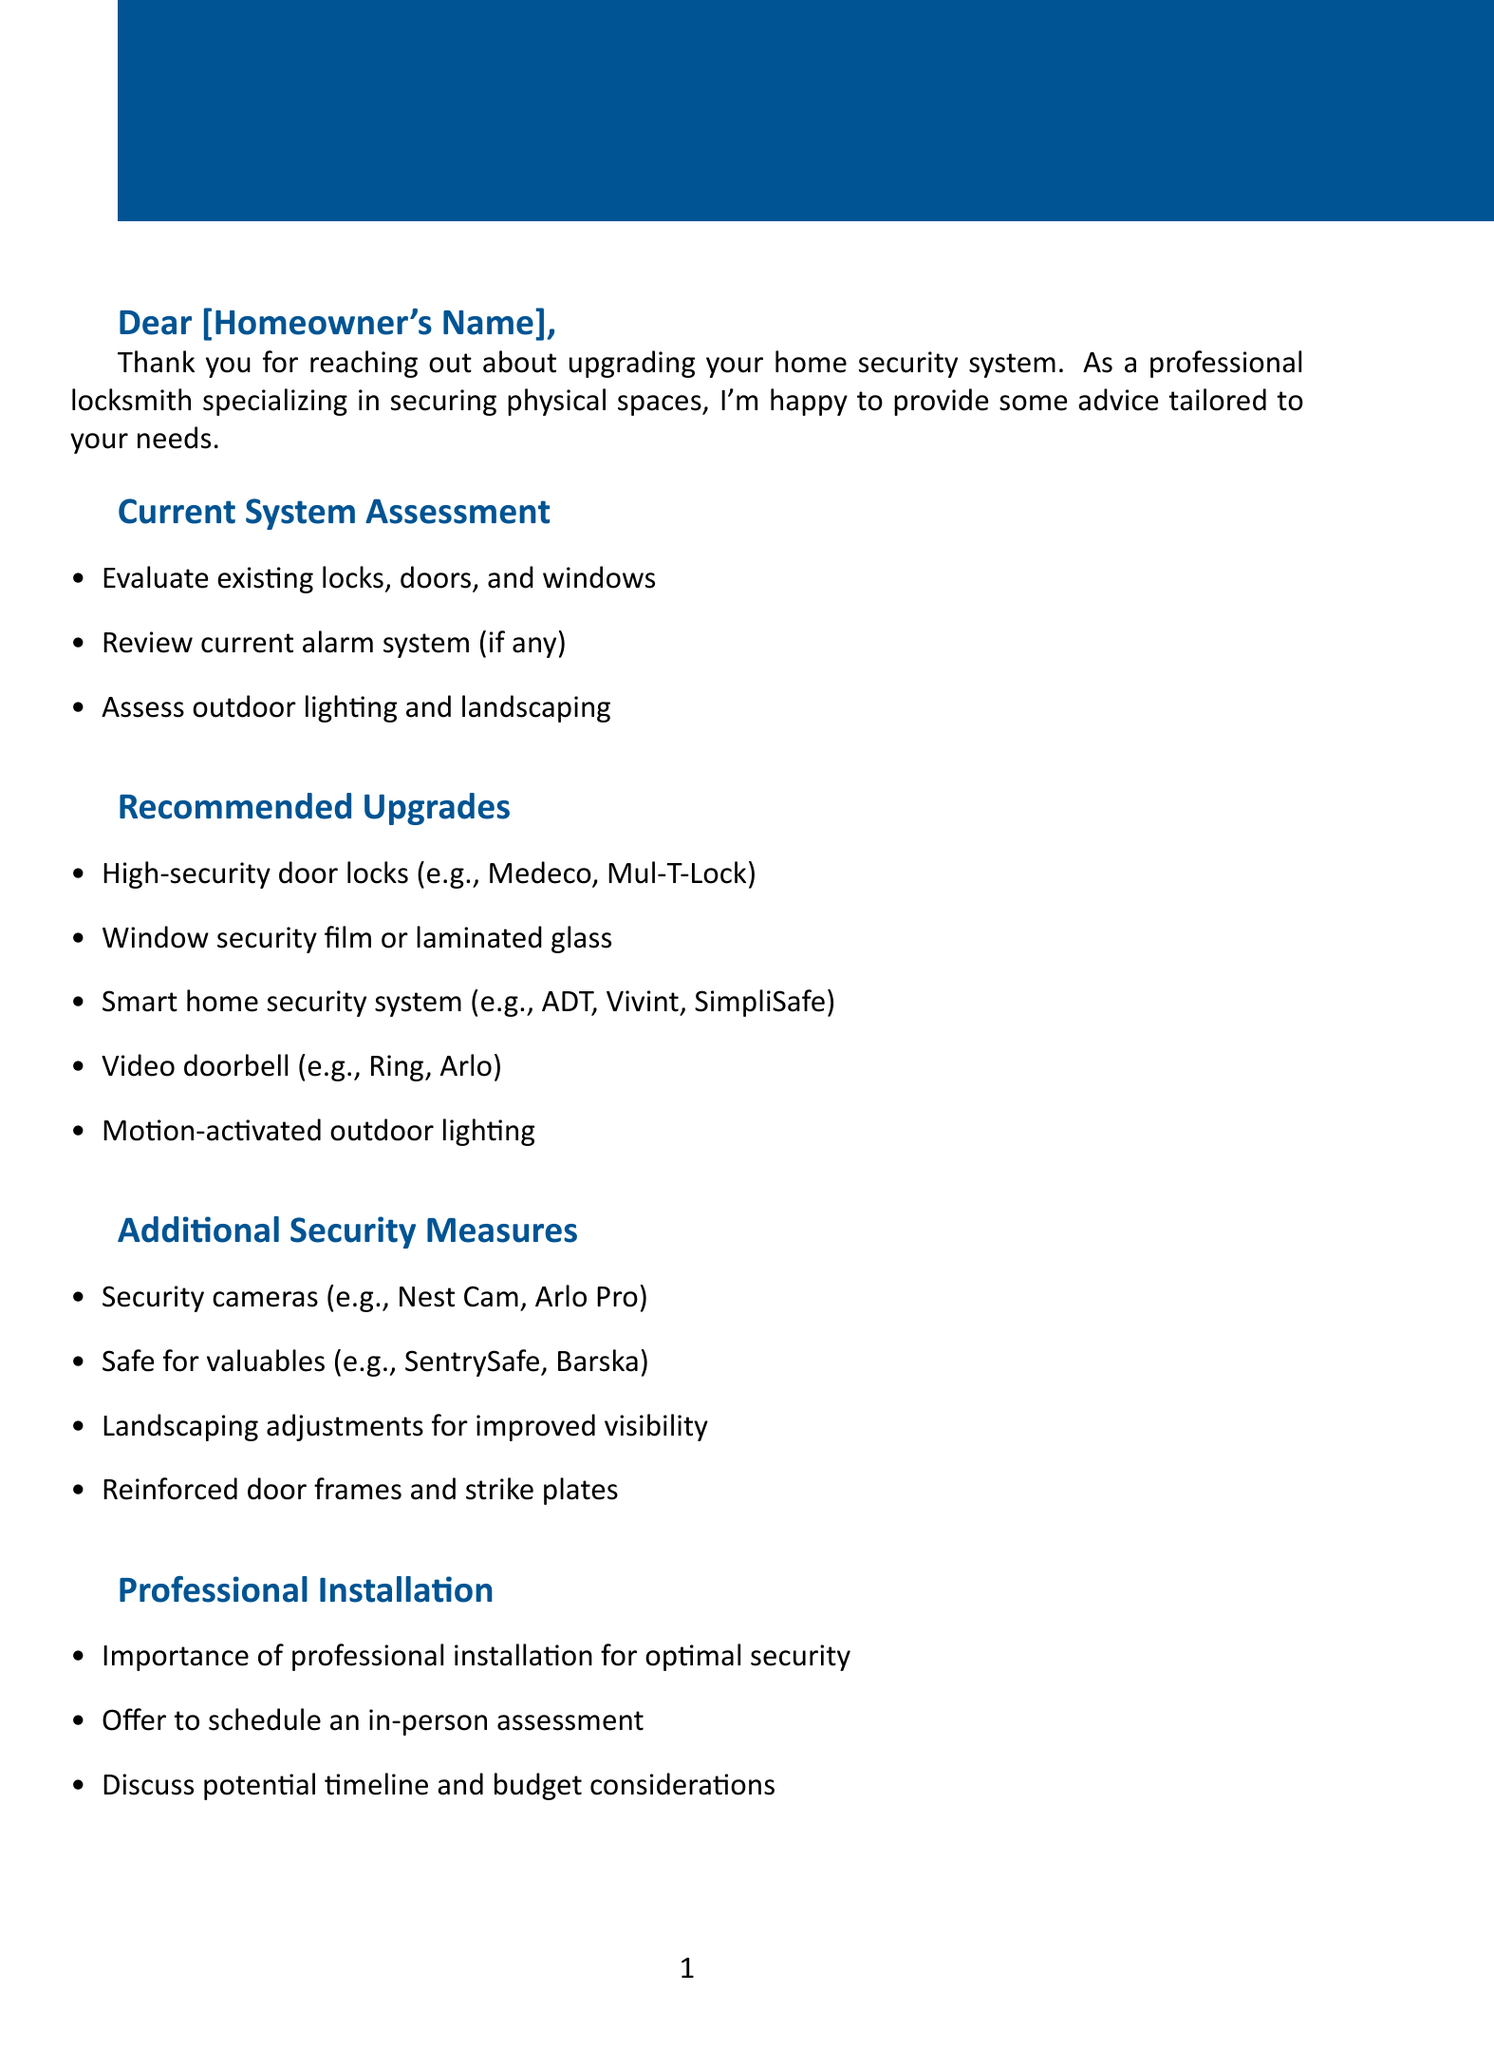What is the greeting in the letter? The greeting is part of the letter structure that addresses the recipient, starting with "Dear."
Answer: Dear [Homeowner's Name], What is one recommended upgrade for windows? The document lists specific security solutions including those for windows under the recommended upgrades section.
Answer: Window security film or laminated glass How often does a burglary occur in the United States? This is a statistical fact mentioned in the additional information section of the document.
Answer: Every 25.7 seconds What is one advantage of having a security system regarding insurance? The document states benefits of security systems related to insurance, highlighting financial aspects for homeowners.
Answer: Discounts for homes with security systems Why is professional installation important? The document emphasizes the need for professional help to ensure proper security measures are taken and discusses this in the context of installation.
Answer: Optimal security What kind of lighting is suggested for enhancing security outdoors? The document includes suggestions for outdoor security measures in the recommended upgrades.
Answer: Motion-activated outdoor lighting What is one maintenance tip provided in the document? The document offers proactive advice for ensuring security systems work effectively, categorized under maintenance.
Answer: Regularly test your alarm system What is included at the end of the letter? The ending of the letter commonly features a farewell and signature, which encapsulates the closing statement to the homeowner.
Answer: Best regards, [Your Name] 